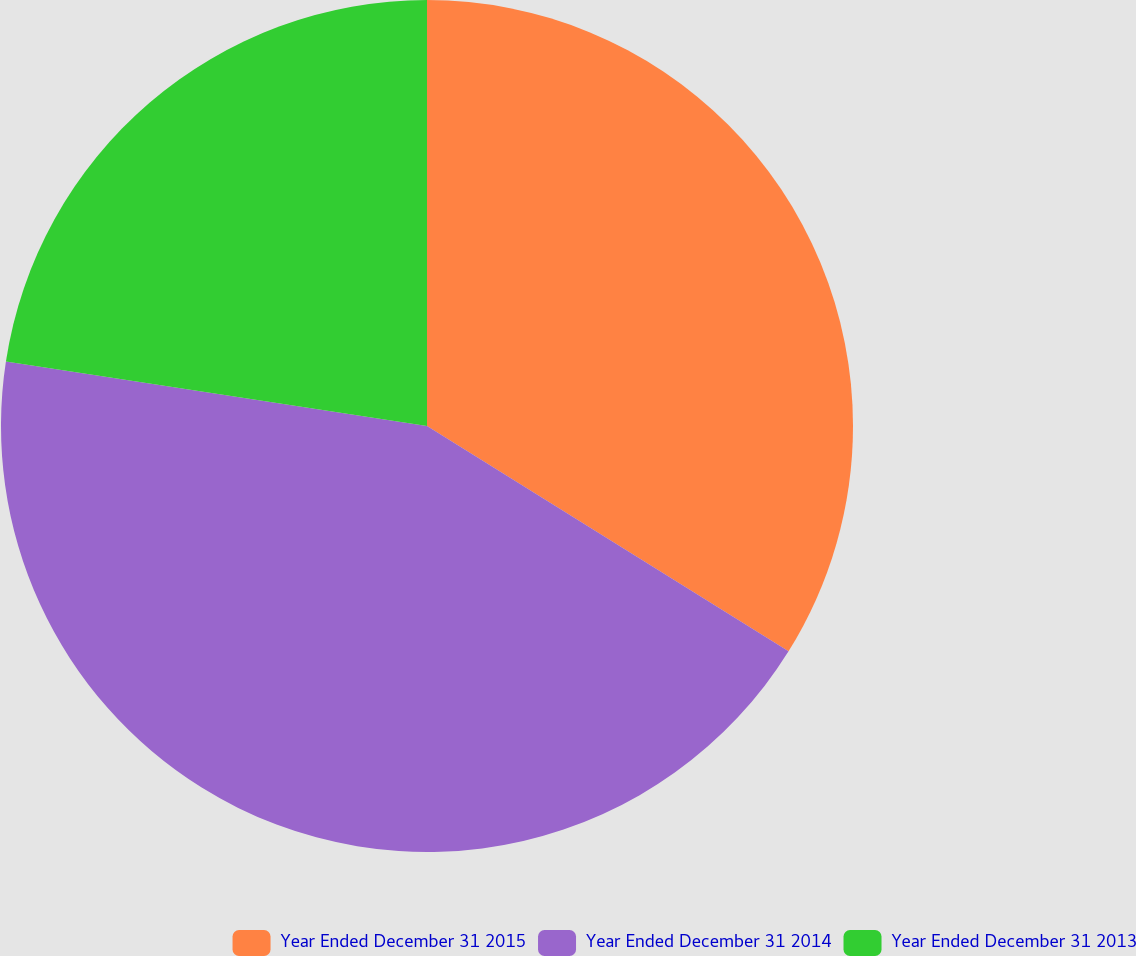Convert chart. <chart><loc_0><loc_0><loc_500><loc_500><pie_chart><fcel>Year Ended December 31 2015<fcel>Year Ended December 31 2014<fcel>Year Ended December 31 2013<nl><fcel>33.87%<fcel>43.55%<fcel>22.58%<nl></chart> 